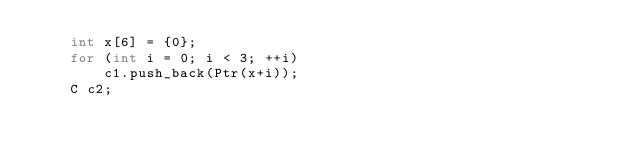<code> <loc_0><loc_0><loc_500><loc_500><_C++_>    int x[6] = {0};
    for (int i = 0; i < 3; ++i)
        c1.push_back(Ptr(x+i));
    C c2;</code> 